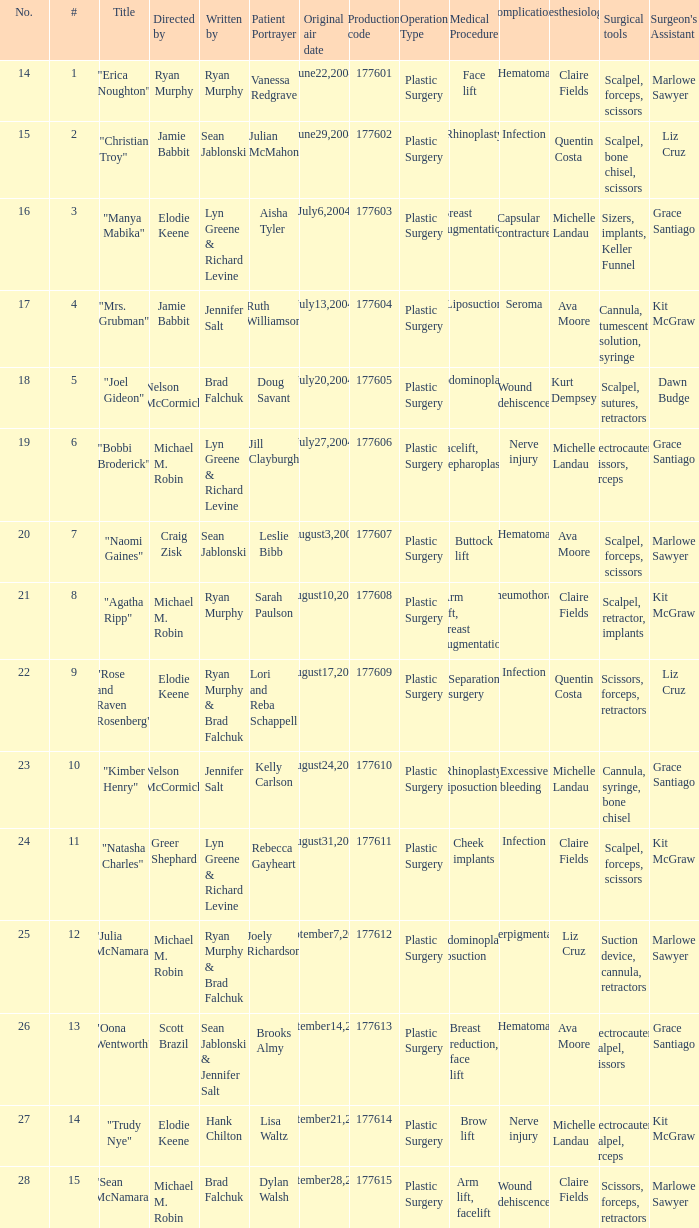What numbered episode is titled "naomi gaines"? 20.0. 